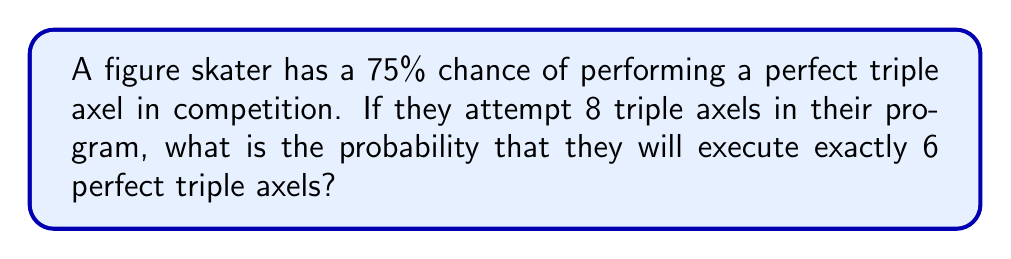Teach me how to tackle this problem. To solve this problem, we can use the binomial probability formula, as we're dealing with a fixed number of independent trials (attempts at triple axels) with two possible outcomes (perfect or not perfect) and a constant probability of success.

The binomial probability formula is:

$$P(X = k) = \binom{n}{k} p^k (1-p)^{n-k}$$

Where:
$n$ = number of trials
$k$ = number of successes
$p$ = probability of success on each trial

Given:
$n = 8$ (total attempts)
$k = 6$ (desired perfect executions)
$p = 0.75$ (75% chance of perfect execution)

Step 1: Calculate the binomial coefficient
$$\binom{8}{6} = \frac{8!}{6!(8-6)!} = \frac{8!}{6!2!} = 28$$

Step 2: Substitute values into the binomial probability formula
$$P(X = 6) = \binom{8}{6} (0.75)^6 (1-0.75)^{8-6}$$
$$P(X = 6) = 28 \cdot (0.75)^6 \cdot (0.25)^2$$

Step 3: Calculate the result
$$P(X = 6) = 28 \cdot 0.1780 \cdot 0.0625 = 0.3111$$

Therefore, the probability of executing exactly 6 perfect triple axels out of 8 attempts is approximately 0.3111 or 31.11%.
Answer: 0.3111 